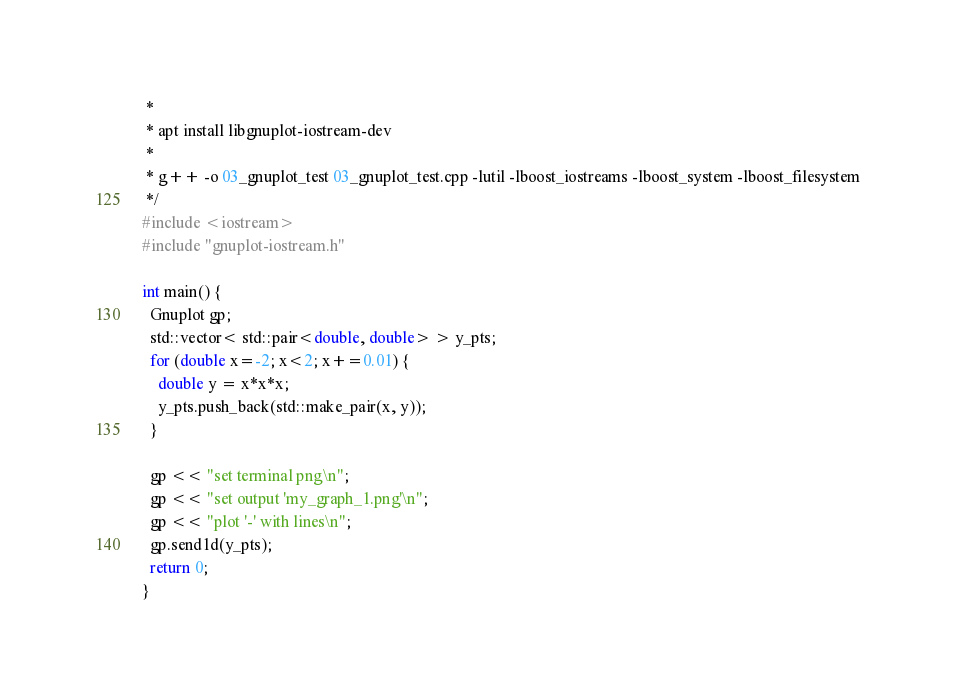<code> <loc_0><loc_0><loc_500><loc_500><_C++_> *
 * apt install libgnuplot-iostream-dev
 *
 * g++ -o 03_gnuplot_test 03_gnuplot_test.cpp -lutil -lboost_iostreams -lboost_system -lboost_filesystem
 */
#include <iostream>
#include "gnuplot-iostream.h"

int main() {
  Gnuplot gp;
  std::vector< std::pair<double, double> > y_pts;
  for (double x=-2; x<2; x+=0.01) {
    double y = x*x*x;
    y_pts.push_back(std::make_pair(x, y));
  }

  gp << "set terminal png\n";
  gp << "set output 'my_graph_1.png'\n";
  gp << "plot '-' with lines\n";
  gp.send1d(y_pts);
  return 0;
}
</code> 